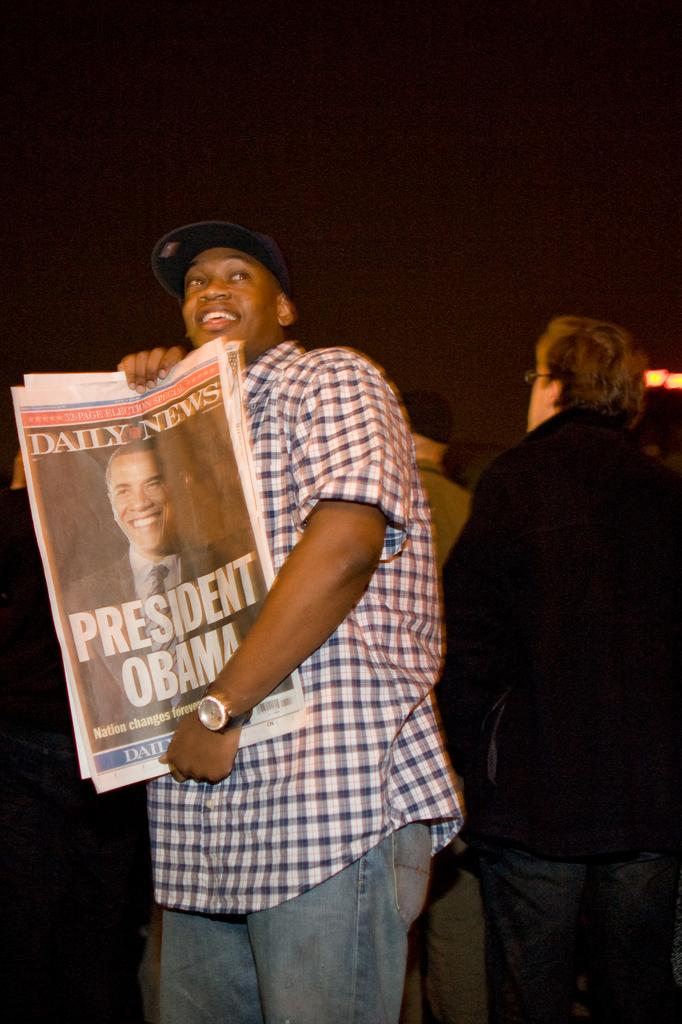What is the person in the image holding? The person in the image is holding posters. Can you describe the people in the background of the image? There are a few people in the background of the image. What news story is being discussed by the people in the image? There is no news story being discussed in the image; it only shows a person holding posters and a few people in the background. 